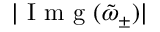<formula> <loc_0><loc_0><loc_500><loc_500>| I m g ( \tilde { \omega } _ { \pm } ) |</formula> 